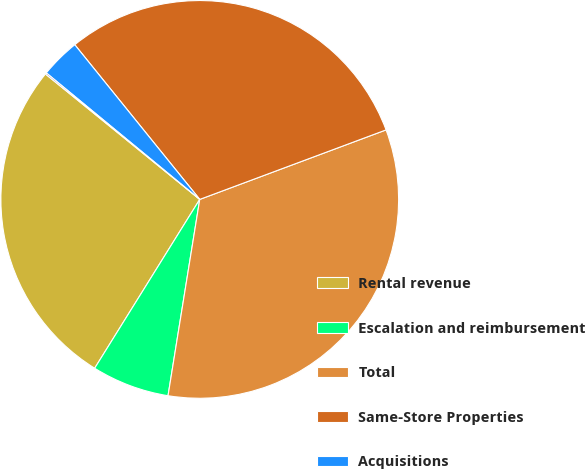<chart> <loc_0><loc_0><loc_500><loc_500><pie_chart><fcel>Rental revenue<fcel>Escalation and reimbursement<fcel>Total<fcel>Same-Store Properties<fcel>Acquisitions<fcel>Other<nl><fcel>27.0%<fcel>6.31%<fcel>33.23%<fcel>30.13%<fcel>3.21%<fcel>0.11%<nl></chart> 